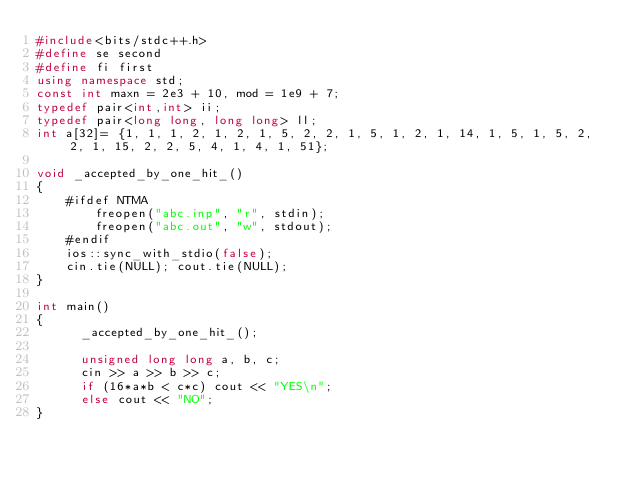Convert code to text. <code><loc_0><loc_0><loc_500><loc_500><_C++_>#include<bits/stdc++.h>
#define se second
#define fi first
using namespace std;
const int maxn = 2e3 + 10, mod = 1e9 + 7;
typedef pair<int,int> ii;
typedef pair<long long, long long> ll;
int a[32]= {1, 1, 1, 2, 1, 2, 1, 5, 2, 2, 1, 5, 1, 2, 1, 14, 1, 5, 1, 5, 2, 2, 1, 15, 2, 2, 5, 4, 1, 4, 1, 51};

void _accepted_by_one_hit_()
{
    #ifdef NTMA
        freopen("abc.inp", "r", stdin);
        freopen("abc.out", "w", stdout);
    #endif
    ios::sync_with_stdio(false);
    cin.tie(NULL); cout.tie(NULL);
}

int main()
{
      _accepted_by_one_hit_();

      unsigned long long a, b, c;
      cin >> a >> b >> c;
      if (16*a*b < c*c) cout << "YES\n";
      else cout << "NO";
}</code> 